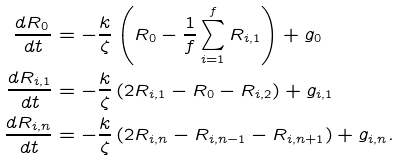Convert formula to latex. <formula><loc_0><loc_0><loc_500><loc_500>\frac { d { R } _ { 0 \, } } { d t } & = - \frac { k } { \zeta } \left ( { R } _ { 0 } - \frac { 1 } { f } \sum _ { i = 1 } ^ { f } { R } _ { i , 1 } \right ) + { g } _ { 0 } \\ \frac { d { R } _ { i , 1 } } { d t } & = - \frac { k } { \zeta } \left ( 2 { R } _ { i , 1 } - { R } _ { 0 } - { R } _ { i , 2 } \right ) + { g } _ { i , 1 } \\ \frac { d { R } _ { i , n } } { d t } & = - \frac { k } { \zeta } \left ( 2 { R } _ { i , n } - { R } _ { i , n - 1 } - { R } _ { i , n + 1 } \right ) + { g } _ { i , n } .</formula> 